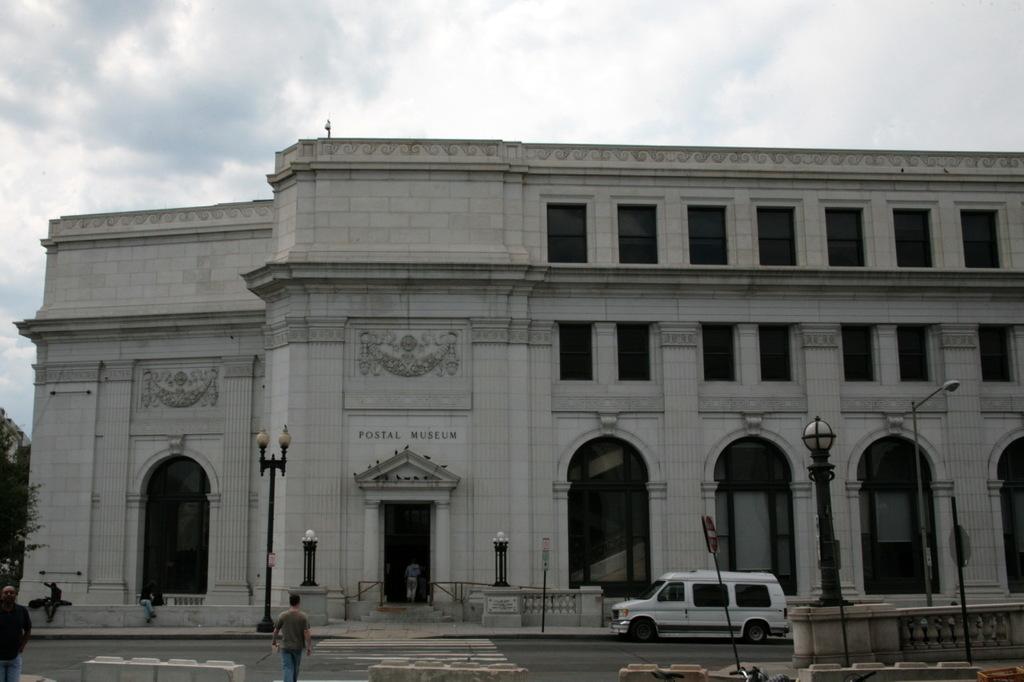What kind of museum is this?
Your answer should be compact. Postal. The name of the building is?
Your answer should be very brief. Postal museum. 